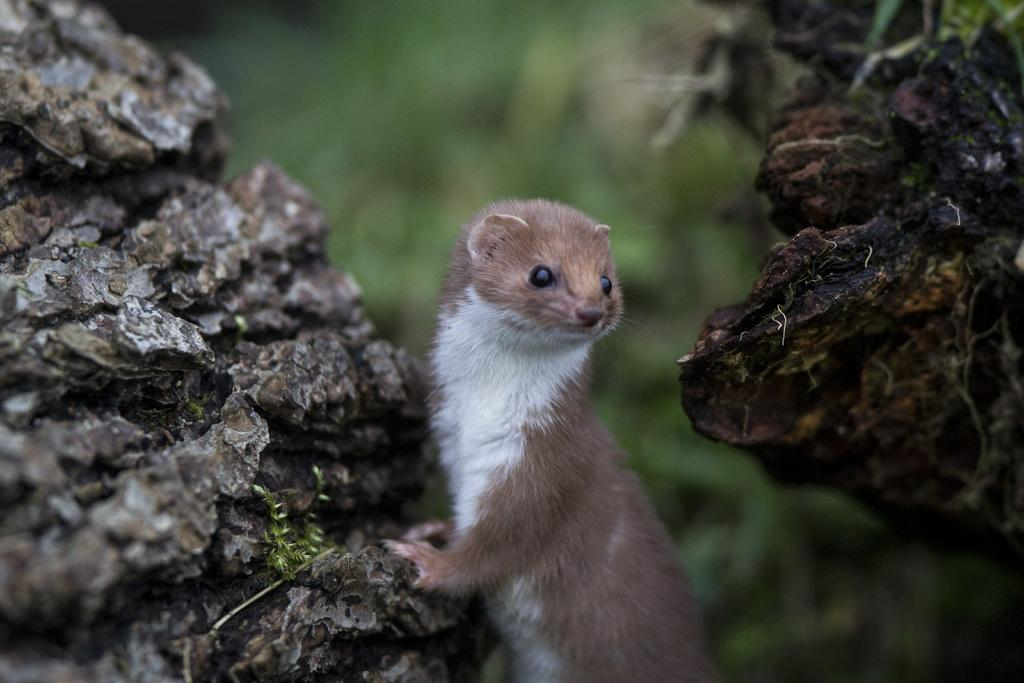What is the main subject in the center of the image? There is an animal in the center of the image. What type of furniture can be seen in the image? There is no furniture present in the image; it features an animal in the center. Is there a record player visible in the image? There is no record player present in the image; it features an animal in the center. 